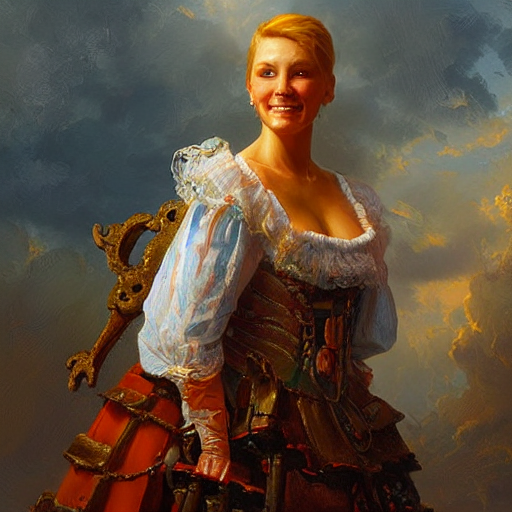What is the condition of the lighting in the image? A. Strong B. Bright C. Weak Answer with the option's letter from the given choices directly. The lighting in the image is bright, warmly illuminating the subject and creating a pleasant ambiance. The strong highlights on the character's face and costume, as well as the vibrant background, suggest that the correct answer is B. Bright. 